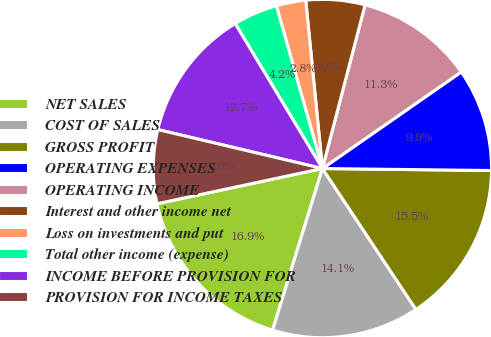Convert chart. <chart><loc_0><loc_0><loc_500><loc_500><pie_chart><fcel>NET SALES<fcel>COST OF SALES<fcel>GROSS PROFIT<fcel>OPERATING EXPENSES<fcel>OPERATING INCOME<fcel>Interest and other income net<fcel>Loss on investments and put<fcel>Total other income (expense)<fcel>INCOME BEFORE PROVISION FOR<fcel>PROVISION FOR INCOME TAXES<nl><fcel>16.9%<fcel>14.08%<fcel>15.49%<fcel>9.86%<fcel>11.27%<fcel>5.63%<fcel>2.82%<fcel>4.23%<fcel>12.68%<fcel>7.04%<nl></chart> 